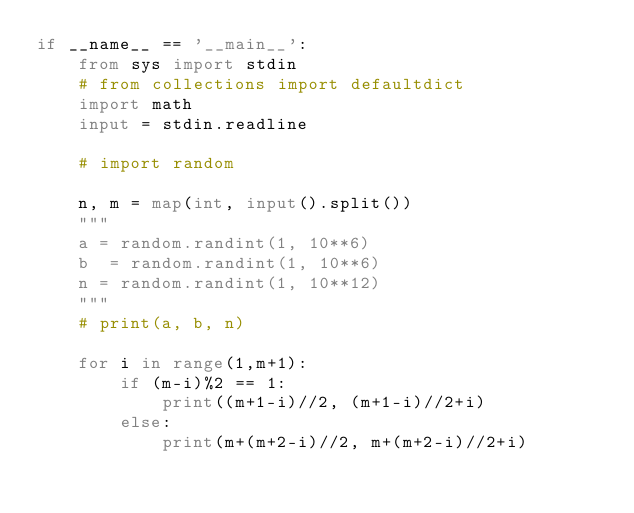<code> <loc_0><loc_0><loc_500><loc_500><_Python_>if __name__ == '__main__':
    from sys import stdin
    # from collections import defaultdict
    import math
    input = stdin.readline

    # import random

    n, m = map(int, input().split())
    """
    a = random.randint(1, 10**6)
    b  = random.randint(1, 10**6)
    n = random.randint(1, 10**12)
    """
    # print(a, b, n)
    
    for i in range(1,m+1):
        if (m-i)%2 == 1:
            print((m+1-i)//2, (m+1-i)//2+i)
        else:
            print(m+(m+2-i)//2, m+(m+2-i)//2+i)

</code> 